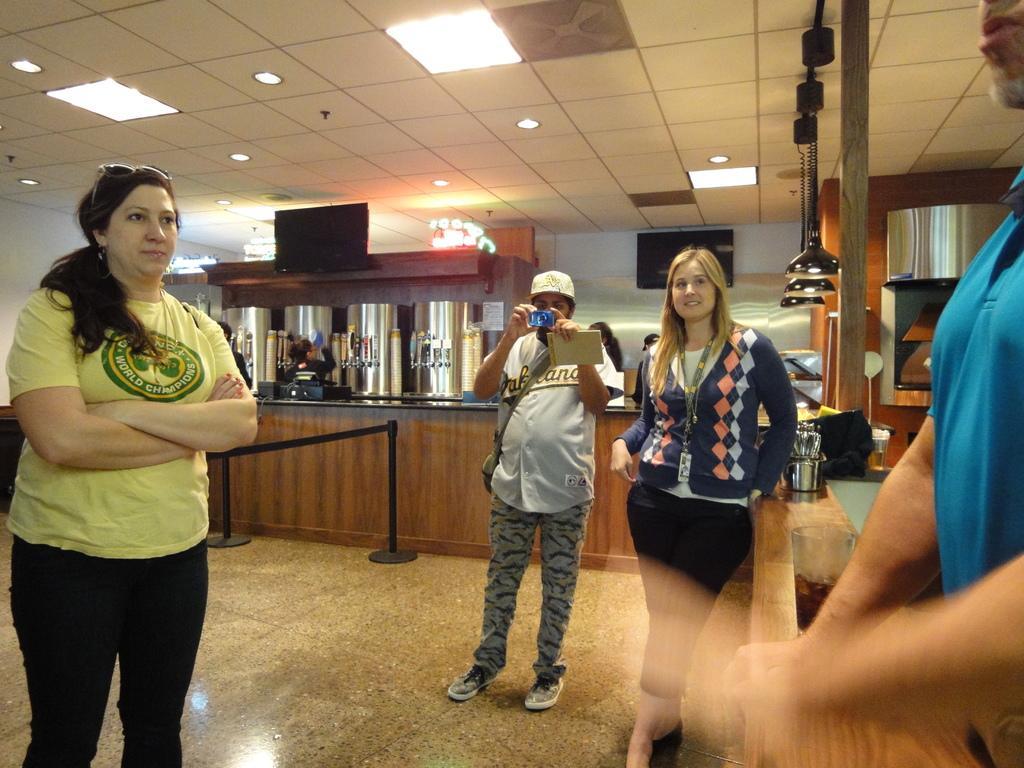How would you summarize this image in a sentence or two? This is an inside view of a room. On the right side there is a man and on the left side there is a woman standing and looking at this man. In the middle of the image there is a woman and a man are standing. The man is holding a camera in the hands and capturing. In the background there is a table on which many objects are placed. On the right side also there is a table on which bowls, a bag and some other objects are placed and also there is a pole. At the top of the image there are few lights. 